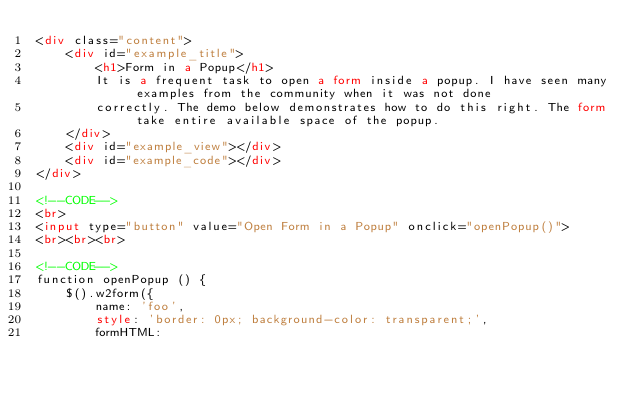Convert code to text. <code><loc_0><loc_0><loc_500><loc_500><_HTML_><div class="content">
	<div id="example_title">
		<h1>Form in a Popup</h1>
		It is a frequent task to open a form inside a popup. I have seen many examples from the community when it was not done
		correctly. The demo below demonstrates how to do this right. The form take entire available space of the popup.
	</div>
	<div id="example_view"></div>
	<div id="example_code"></div>
</div>

<!--CODE-->
<br>
<input type="button" value="Open Form in a Popup" onclick="openPopup()">
<br><br><br>

<!--CODE-->
function openPopup () {
	$().w2form({
		name: 'foo',
		style: 'border: 0px; background-color: transparent;',
		formHTML: </code> 